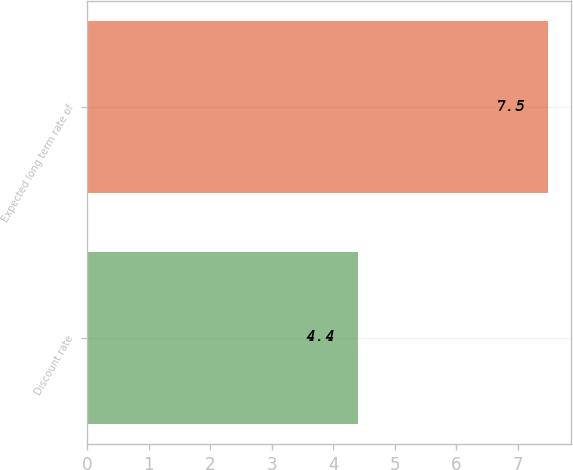Convert chart to OTSL. <chart><loc_0><loc_0><loc_500><loc_500><bar_chart><fcel>Discount rate<fcel>Expected long term rate of<nl><fcel>4.4<fcel>7.5<nl></chart> 